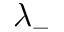Convert formula to latex. <formula><loc_0><loc_0><loc_500><loc_500>\lambda _ { - }</formula> 